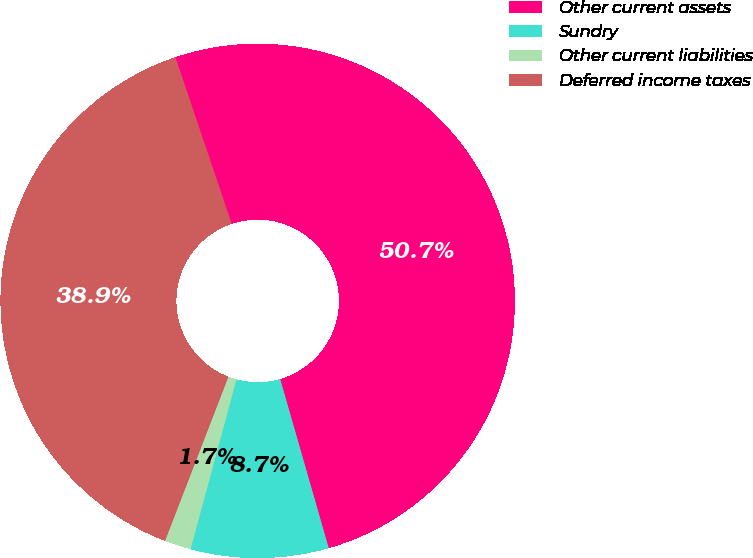Convert chart. <chart><loc_0><loc_0><loc_500><loc_500><pie_chart><fcel>Other current assets<fcel>Sundry<fcel>Other current liabilities<fcel>Deferred income taxes<nl><fcel>50.74%<fcel>8.66%<fcel>1.66%<fcel>38.95%<nl></chart> 